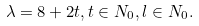<formula> <loc_0><loc_0><loc_500><loc_500>\lambda = 8 + 2 t , t \in N _ { 0 } , l \in N _ { 0 } .</formula> 